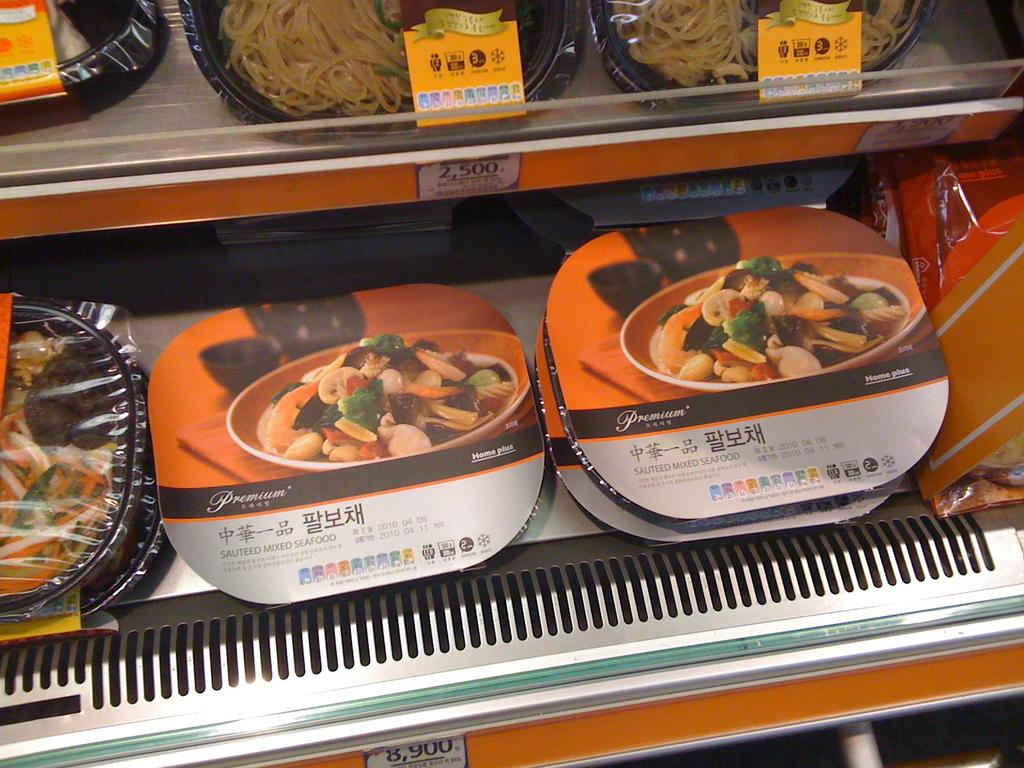What type of objects can be seen in the image? There are food boxes in the image. How are the food boxes arranged? The food boxes are in racks. Are there any additional details about the food boxes? Price notes are visible in the image. Can you see any rabbits interacting with the food boxes in the image? There are no rabbits present in the image. What type of seed is used to grow the food boxes in the image? The image does not show any seeds or information about how the food boxes were grown. 